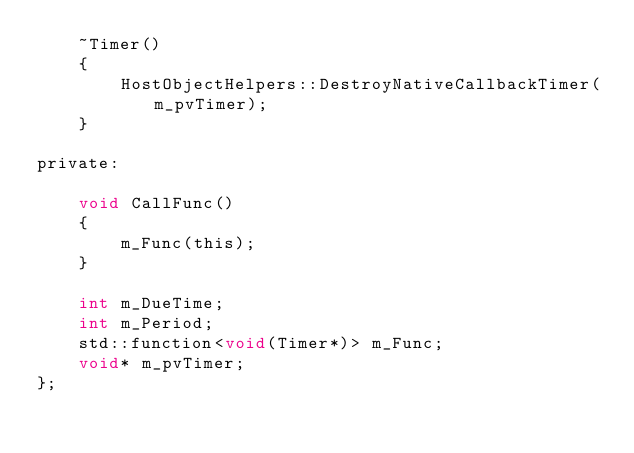Convert code to text. <code><loc_0><loc_0><loc_500><loc_500><_C_>    ~Timer()
    {
        HostObjectHelpers::DestroyNativeCallbackTimer(m_pvTimer);
    }

private:

    void CallFunc()
    {
        m_Func(this);
    }

    int m_DueTime;
    int m_Period;
    std::function<void(Timer*)> m_Func;
    void* m_pvTimer;
};
</code> 